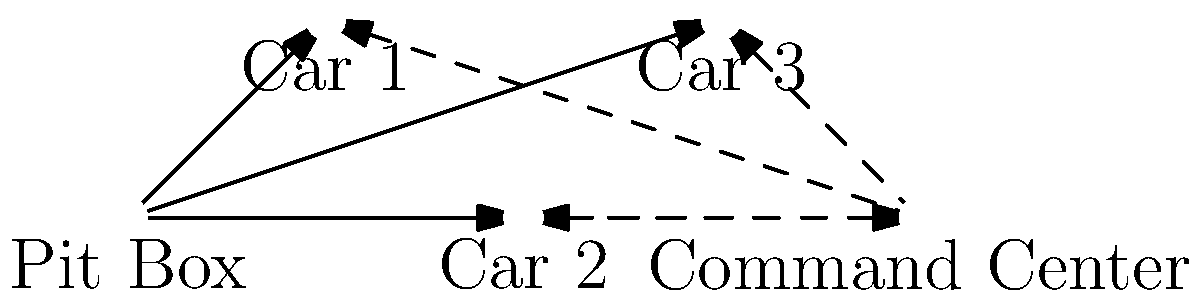In the given network topology diagram for pit lane communication, what is the minimum number of communication links that need to fail for the Command Center to lose direct contact with all race cars? To solve this problem, we need to analyze the network topology diagram and understand the connections between the Command Center and the race cars. Let's break it down step-by-step:

1. Identify the connections:
   - The Command Center has direct links (dashed lines) to Car 1, Car 2, and Car 3.
   - The Pit Box has direct links (solid lines) to Car 1, Car 2, and Car 3.
   - There's a link between the Command Center and the Pit Box.

2. Analyze the possible failure scenarios:
   - If the three direct links from the Command Center to the cars fail, the Command Center can still communicate through the Pit Box.
   - If the link between the Command Center and the Pit Box fails, the Command Center can still communicate directly with the cars.

3. Determine the minimum number of link failures:
   - To lose all direct contact, both the direct links to the cars AND the link to the Pit Box must fail.
   - This means a minimum of 4 links need to fail:
     a. Command Center to Car 1
     b. Command Center to Car 2
     c. Command Center to Car 3
     d. Command Center to Pit Box

4. Verify:
   - If these 4 links fail, the Command Center has no way to communicate with any car, either directly or through the Pit Box.
   - Any fewer link failures would leave at least one communication path open.

Therefore, the minimum number of communication links that need to fail for the Command Center to lose direct contact with all race cars is 4.
Answer: 4 links 